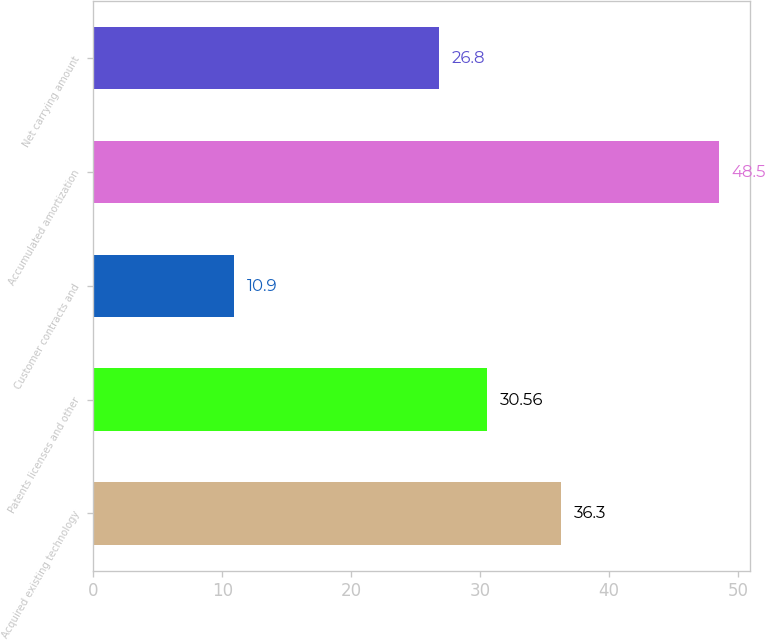Convert chart. <chart><loc_0><loc_0><loc_500><loc_500><bar_chart><fcel>Acquired existing technology<fcel>Patents licenses and other<fcel>Customer contracts and<fcel>Accumulated amortization<fcel>Net carrying amount<nl><fcel>36.3<fcel>30.56<fcel>10.9<fcel>48.5<fcel>26.8<nl></chart> 